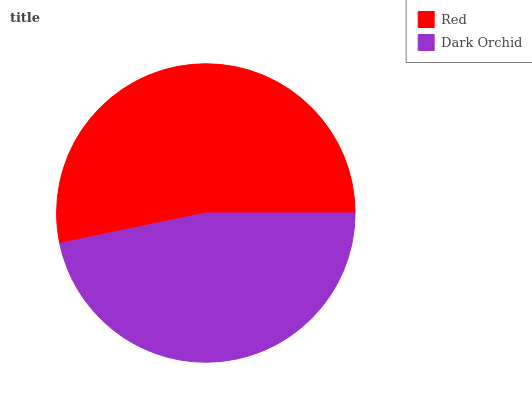Is Dark Orchid the minimum?
Answer yes or no. Yes. Is Red the maximum?
Answer yes or no. Yes. Is Dark Orchid the maximum?
Answer yes or no. No. Is Red greater than Dark Orchid?
Answer yes or no. Yes. Is Dark Orchid less than Red?
Answer yes or no. Yes. Is Dark Orchid greater than Red?
Answer yes or no. No. Is Red less than Dark Orchid?
Answer yes or no. No. Is Red the high median?
Answer yes or no. Yes. Is Dark Orchid the low median?
Answer yes or no. Yes. Is Dark Orchid the high median?
Answer yes or no. No. Is Red the low median?
Answer yes or no. No. 